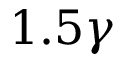<formula> <loc_0><loc_0><loc_500><loc_500>1 . 5 \gamma</formula> 